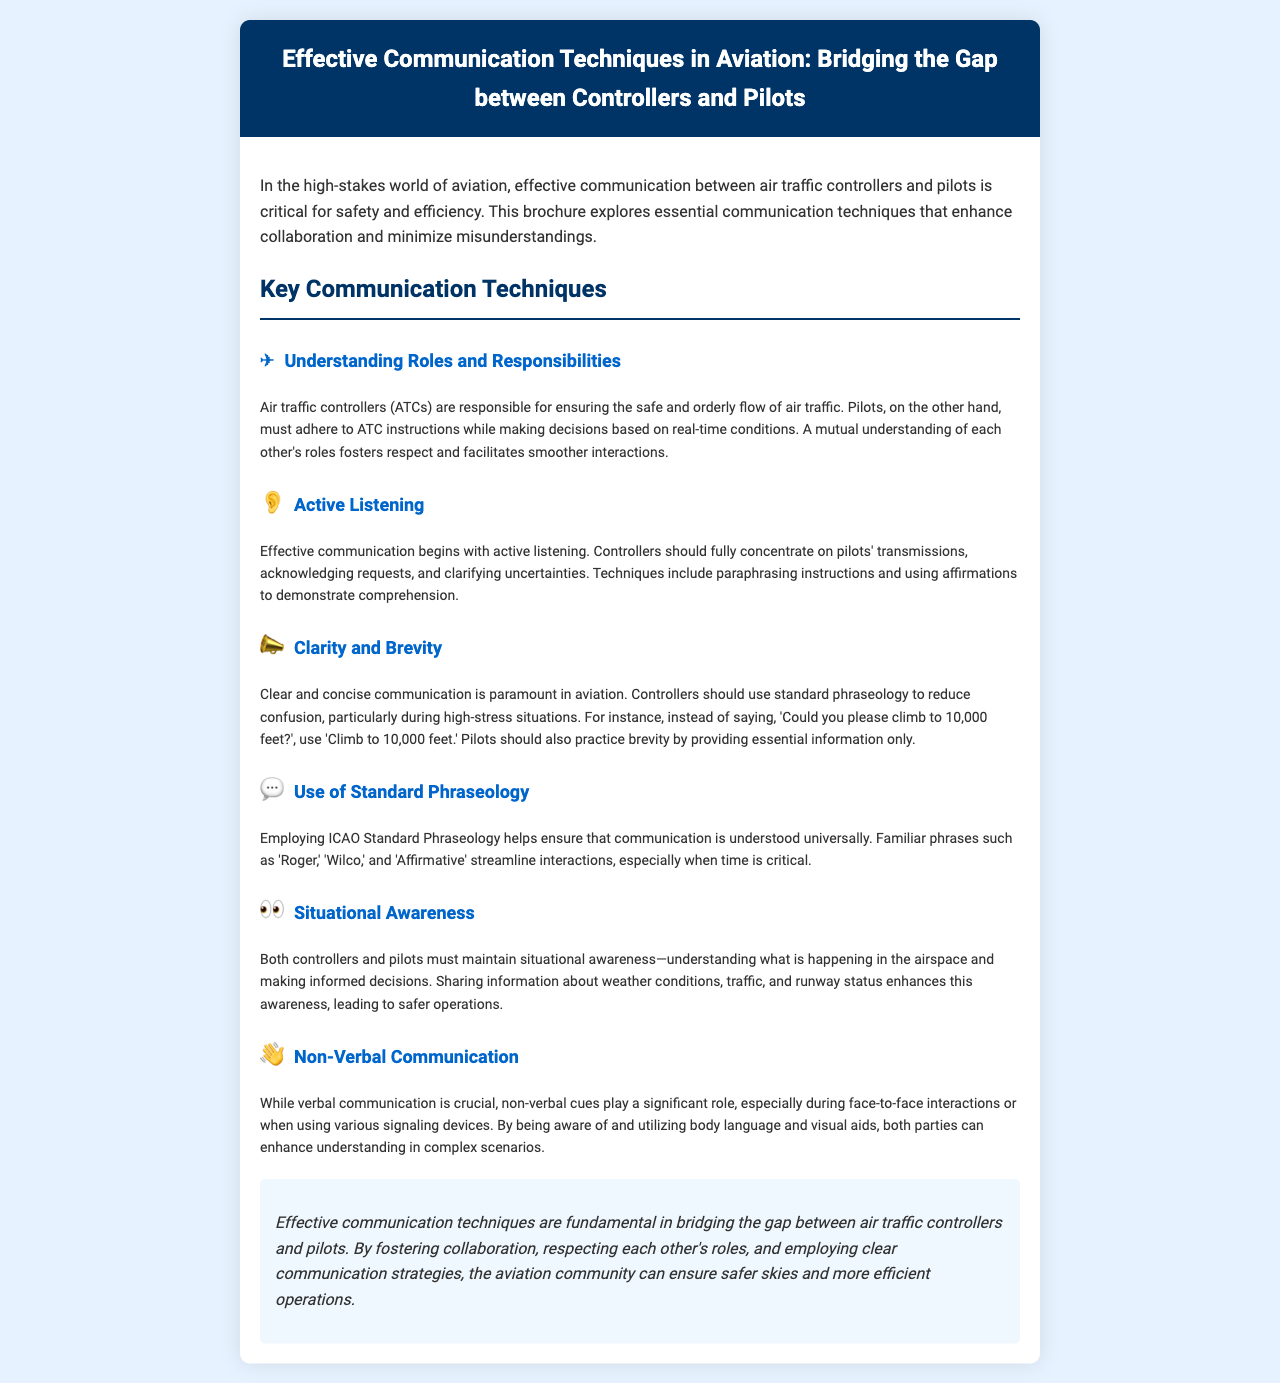what is the title of the brochure? The title of the brochure is stated at the top of the document in the header section.
Answer: Effective Communication Techniques in Aviation: Bridging the Gap between Controllers and Pilots how many key communication techniques are mentioned? The document lists out several key communication techniques in a specific section.
Answer: six which section discusses clarity and brevity? Each section is clearly defined with headings. The heading for clarity and brevity is directly provided in the document.
Answer: Clarity and Brevity what is one technique of active listening mentioned? Active listening techniques are described in the section about active listening. One technique is provided specifically.
Answer: paraphrasing instructions which phraseology is recommended to ensure understanding? The document emphasizes the importance of using standard phraseology, which is a specific recommendation in the content.
Answer: ICAO Standard Phraseology name a key factor in maintaining situational awareness. The section on situational awareness discusses several factors and emphasizes one of them specifically for better understanding.
Answer: sharing information 